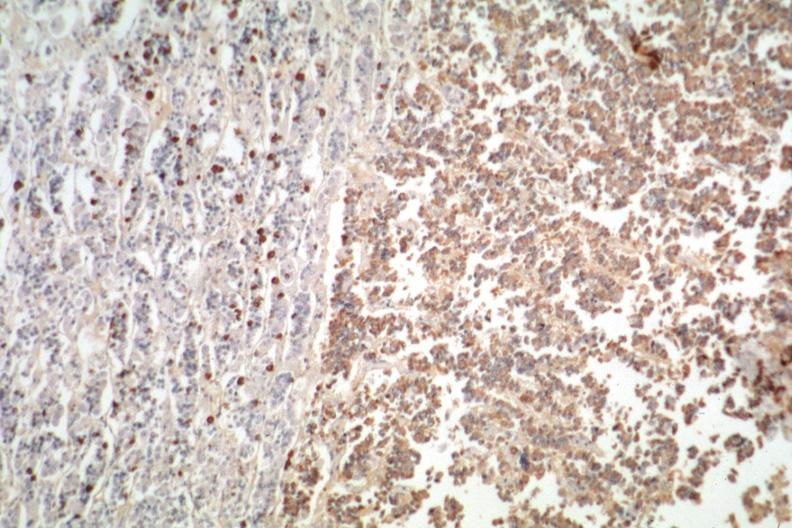do immunostain for growth hormone stain is positive?
Answer the question using a single word or phrase. Yes 